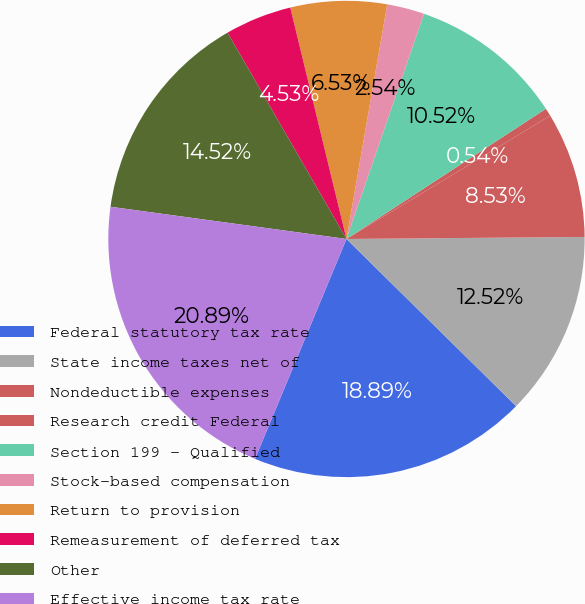<chart> <loc_0><loc_0><loc_500><loc_500><pie_chart><fcel>Federal statutory tax rate<fcel>State income taxes net of<fcel>Nondeductible expenses<fcel>Research credit Federal<fcel>Section 199 - Qualified<fcel>Stock-based compensation<fcel>Return to provision<fcel>Remeasurement of deferred tax<fcel>Other<fcel>Effective income tax rate<nl><fcel>18.89%<fcel>12.52%<fcel>8.53%<fcel>0.54%<fcel>10.52%<fcel>2.54%<fcel>6.53%<fcel>4.53%<fcel>14.52%<fcel>20.89%<nl></chart> 